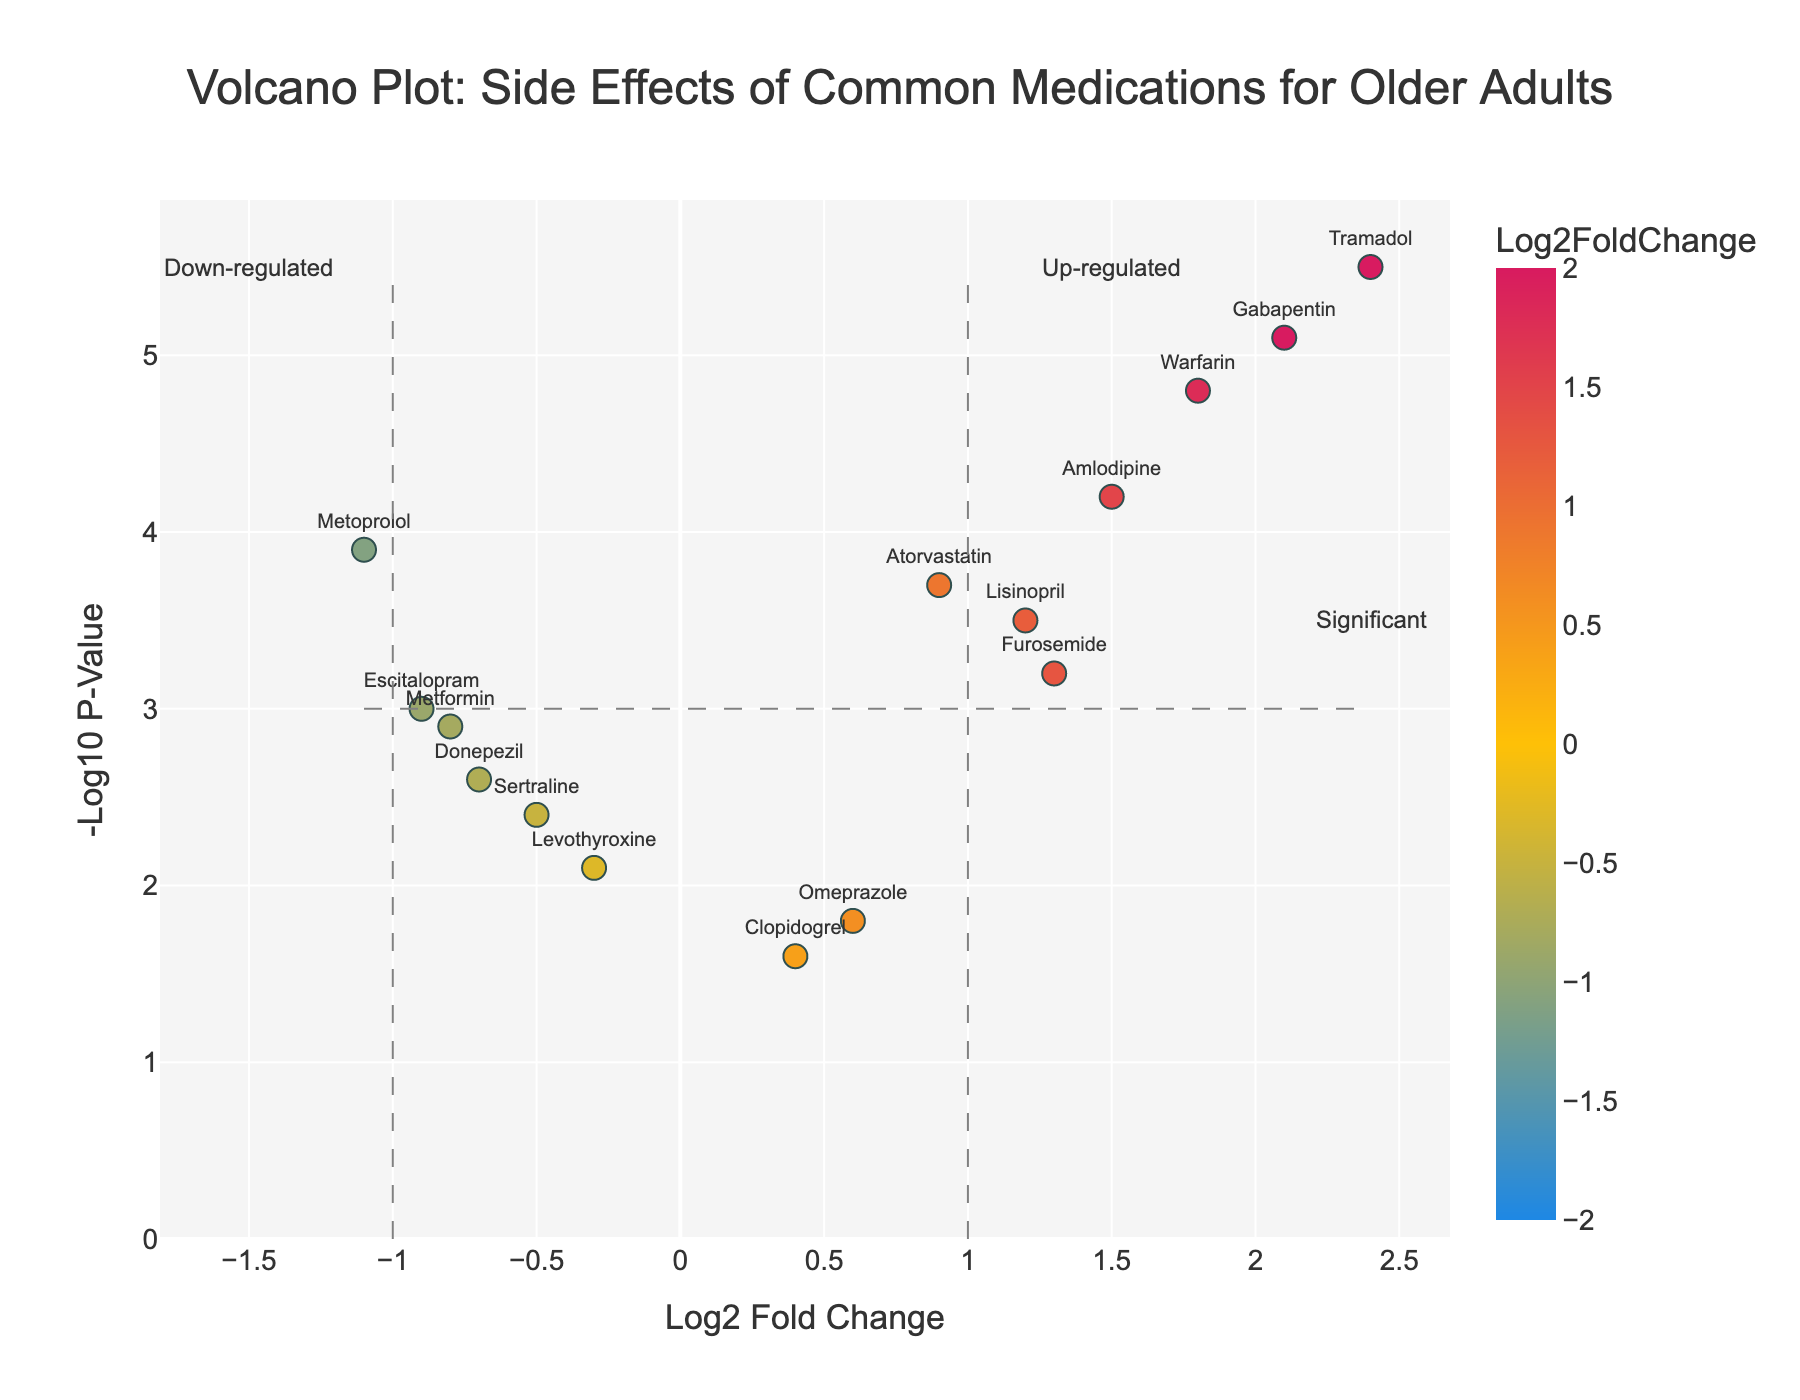What's the title of the plot? The title of the plot is displayed at the top and is usually the most prominent text in the figure.
Answer: Volcano Plot: Side Effects of Common Medications for Older Adults What are the labels of the axes? The labels of the axes are typically located near the edges of the figure, with the x-axis label at the bottom and the y-axis label along the left side.
Answer: Log2 Fold Change (x-axis), -Log10 P-Value (y-axis) How many medications have a Log2FoldChange greater than 1? Count the data points that lie to the right of the vertical dashed line at x=1.
Answer: 6 Which medication has the highest -Log10 P-Value? Find the data point that is furthest up on the y-axis.
Answer: Tramadol Are there more up-regulated or down-regulated medications? Count the data points to the right of x=0 (up-regulated) and the left of x=0 (down-regulated) and compare.
Answer: Up-regulated Which medication is the most down-regulated? Look for the data point furthest to the left on the x-axis.
Answer: Metoprolol Which two medications have similar -Log10 P-Values but opposite Log2FoldChanges? Identify pairs of points that have similar heights (y-axis) but are on opposite sides of the vertical y-axis.
Answer: Metoprolol and Warfarin What is the Log2FoldChange value for Gabapentin? Find the data point labeled Gabapentin and note its x-axis value.
Answer: 2.1 Which medications are considered statistically significant based on the p-value threshold? Identify the data points above the horizontal dashed line at y=3.
Answer: Lisinopril, Amlodipine, Atorvastatin, Metoprolol, Gabapentin, Warfarin, Tramadol, Escitalopram Out of Lisinopril and Amlodipine, which one has higher Log2FoldChange? Compare the x-axis values of the data points labeled Lisinopril and Amlodipine.
Answer: Amlodipine 